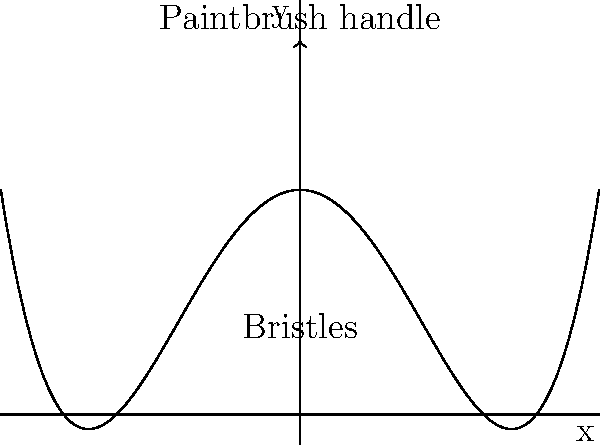Imagine you're creating a special paintbrush shape for your art project. You want to make a polynomial function graph that looks like a paintbrush. The handle of the brush should be at the y-axis, pointing upwards, and the bristles should curve outwards on both sides. Which of the following polynomial functions would best represent this paintbrush shape?

a) $f(x) = 0.05x^4 - 0.8x^2 + 3$
b) $f(x) = -0.05x^4 + 0.8x^2 + 3$
c) $f(x) = 0.05x^3 - 0.8x^2 + 3$
d) $f(x) = -0.05x^4 - 0.8x^2 + 3$ Let's analyze each option to determine which one best represents a paintbrush shape:

1. First, we need a function that has a "U" shape for the bristles and extends upwards for the handle.

2. The term $x^4$ with a positive coefficient will give us the outward curve for the bristles.

3. The term $-0.8x^2$ will make the curve narrower, representing the gathered bristles near the handle.

4. The constant term +3 will shift the entire graph upwards, allowing space for the bristles below the x-axis.

Now, let's examine each option:

a) $f(x) = 0.05x^4 - 0.8x^2 + 3$
   This function has the correct shape: $x^4$ for outward curves, $-x^2$ for narrowing, and +3 for upward shift.

b) $f(x) = -0.05x^4 + 0.8x^2 + 3$
   The negative $x^4$ term would make the bristles curve inward, which is incorrect.

c) $f(x) = 0.05x^3 - 0.8x^2 + 3$
   An $x^3$ term would make the graph asymmetrical, which doesn't represent a paintbrush well.

d) $f(x) = -0.05x^4 - 0.8x^2 + 3$
   Both negative terms would make the graph curve downward, which is incorrect for a paintbrush shape.

Therefore, option a) $f(x) = 0.05x^4 - 0.8x^2 + 3$ is the best representation of a paintbrush shape.
Answer: a) $f(x) = 0.05x^4 - 0.8x^2 + 3$ 